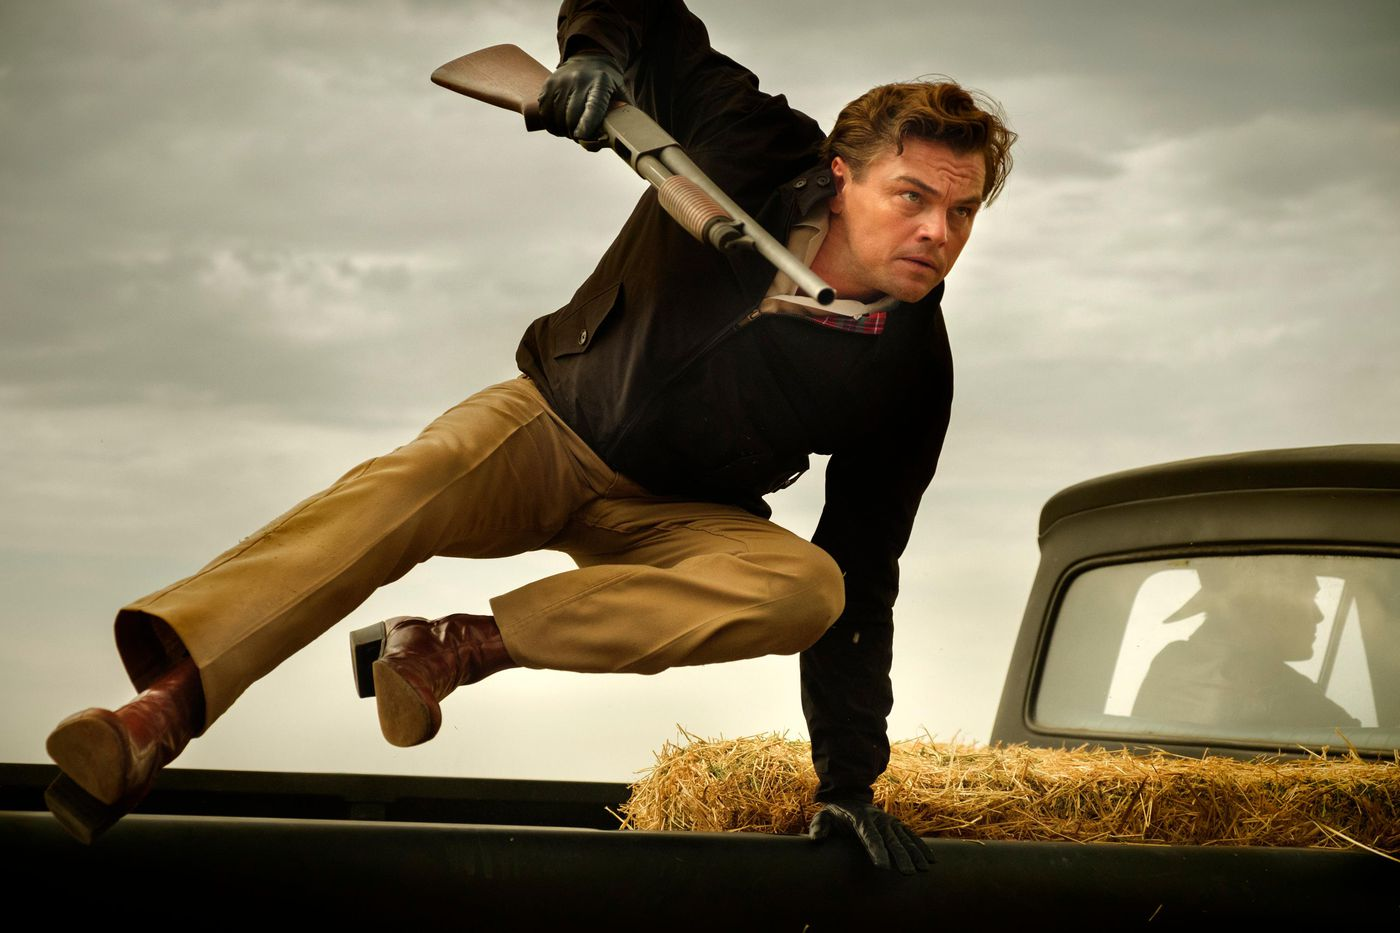What kind of scene is this? How might it fit into a larger narrative? This action-packed scene appears to be a critical moment of high intensity, potentially fitting into a larger narrative involving a pursuit or confrontation. It could be the climactic turn where the protagonist takes decisive action against antagonists or overcomes a major obstacle. As part of a larger storyline, this image might depict the hero escaping from enemy forces, attempting a daring rescue, or making a desperate last stand. The rural setting, combined with the tension-filled atmosphere, enhances the possibility of a storyline filled with rugged resilience, survival, and dramatic standoffs. 